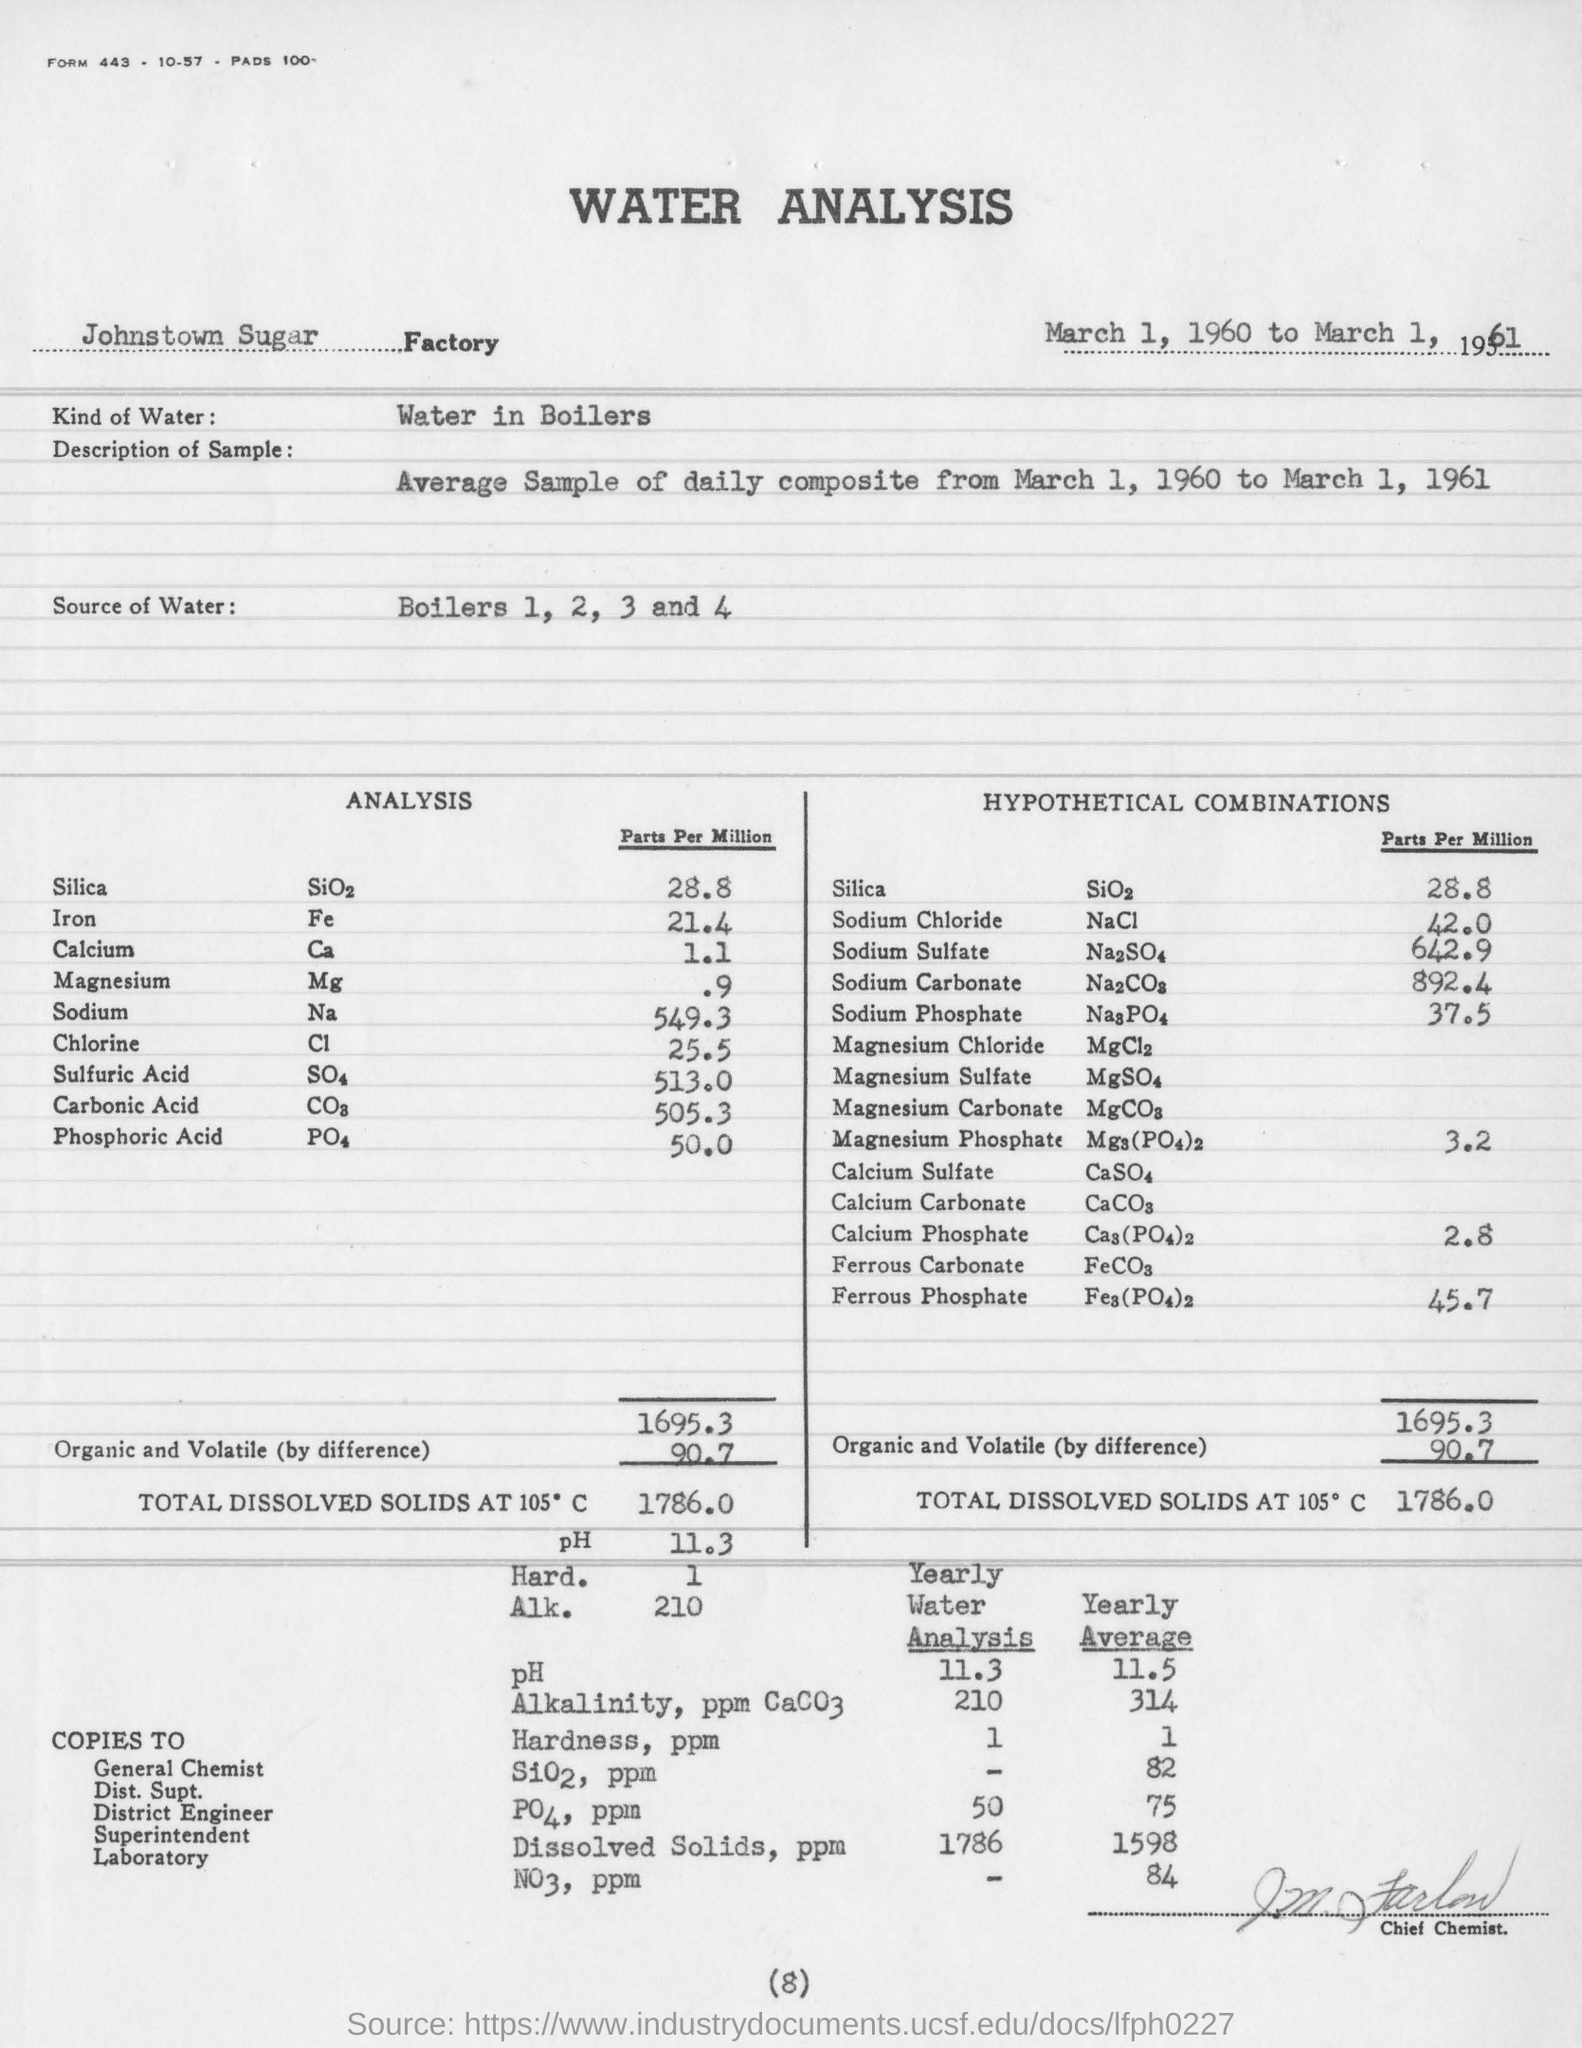Specify some key components in this picture. The analysis showed that the concentration of Sodium was 549.3 parts per million. The source of water for the analysis is boilers 1, 2, 3, and 4. The type of water used for the analysis is typically water from boilers, which is typically heated to high temperatures. The analysis is conducted in the Johnstown Sugar factory. This is a descriptive sentence that states the sample being referred to is an "average sample of daily composite from March 1, 1960 to March 1, 1961. 